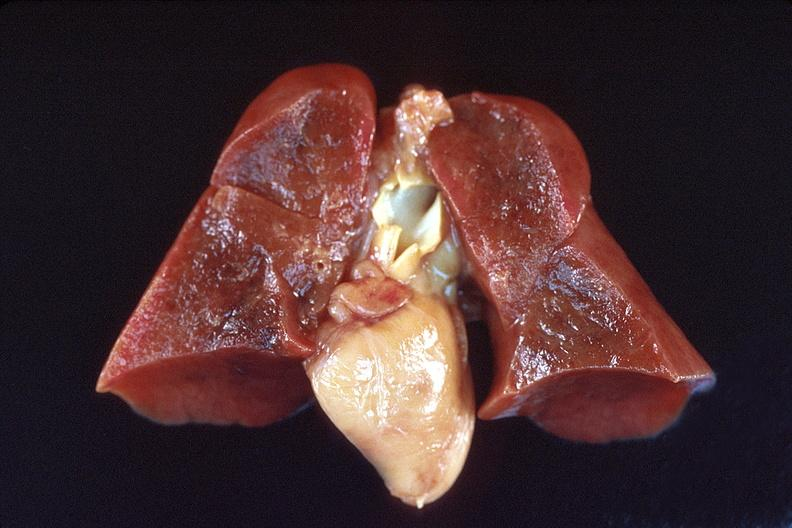where is this?
Answer the question using a single word or phrase. Lung 